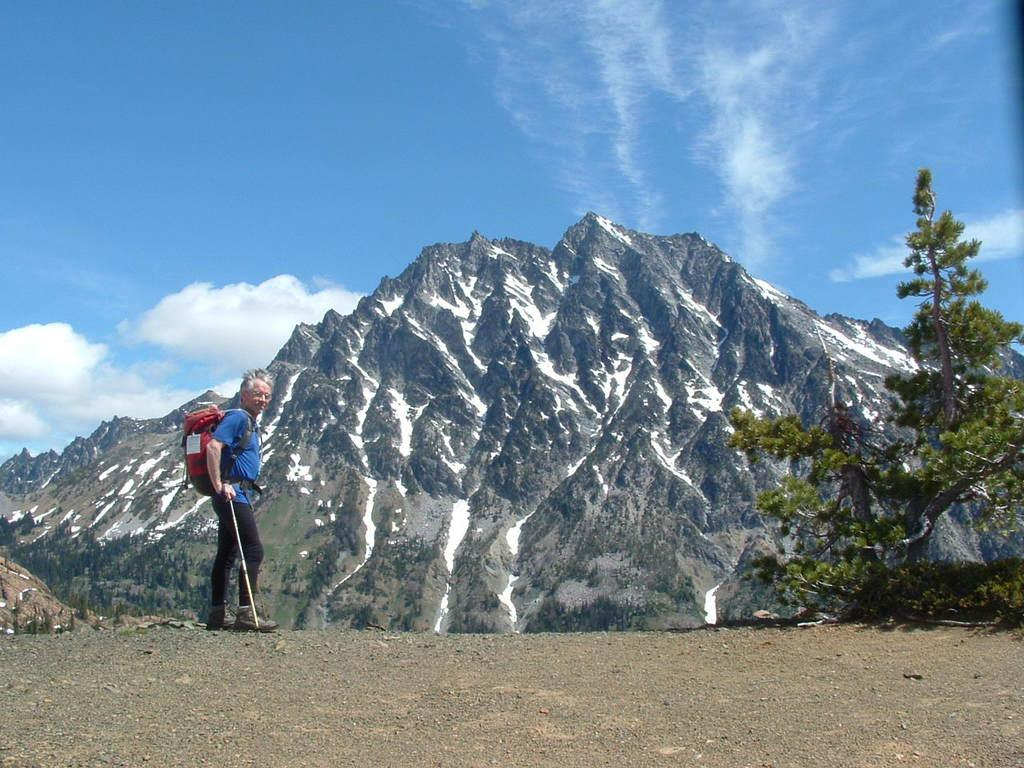What is the person in the image doing? The person is standing and holding a stick in the image. What can be seen near the person? There are trees near the person. What type of objects are present on the ground in the image? There are stones in the image. What can be seen in the distance in the image? There are hills visible in the background of the image. What is visible at the top of the image? The sky is visible at the top of the image, and clouds are present in the sky. What type of hat is the person wearing in the image? There is no hat visible in the image; the person is only holding a stick. How many quinces are present in the image? There are no quinces present in the image. 